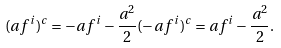<formula> <loc_0><loc_0><loc_500><loc_500>( a f ^ { i } ) ^ { c } = - a f ^ { i } - \frac { a ^ { 2 } } { 2 } ( - a f ^ { i } ) ^ { c } = a f ^ { i } - \frac { a ^ { 2 } } { 2 } .</formula> 